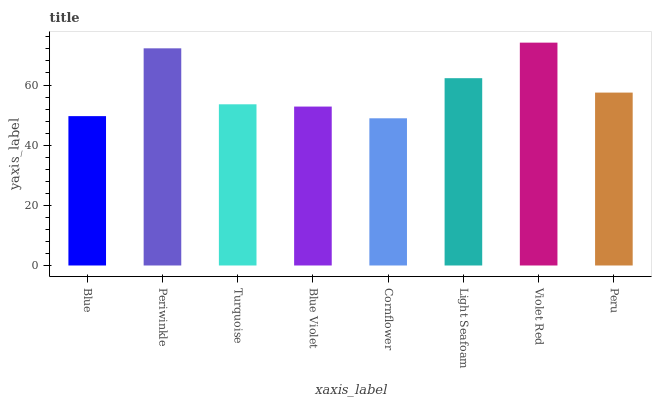Is Cornflower the minimum?
Answer yes or no. Yes. Is Violet Red the maximum?
Answer yes or no. Yes. Is Periwinkle the minimum?
Answer yes or no. No. Is Periwinkle the maximum?
Answer yes or no. No. Is Periwinkle greater than Blue?
Answer yes or no. Yes. Is Blue less than Periwinkle?
Answer yes or no. Yes. Is Blue greater than Periwinkle?
Answer yes or no. No. Is Periwinkle less than Blue?
Answer yes or no. No. Is Peru the high median?
Answer yes or no. Yes. Is Turquoise the low median?
Answer yes or no. Yes. Is Violet Red the high median?
Answer yes or no. No. Is Blue the low median?
Answer yes or no. No. 